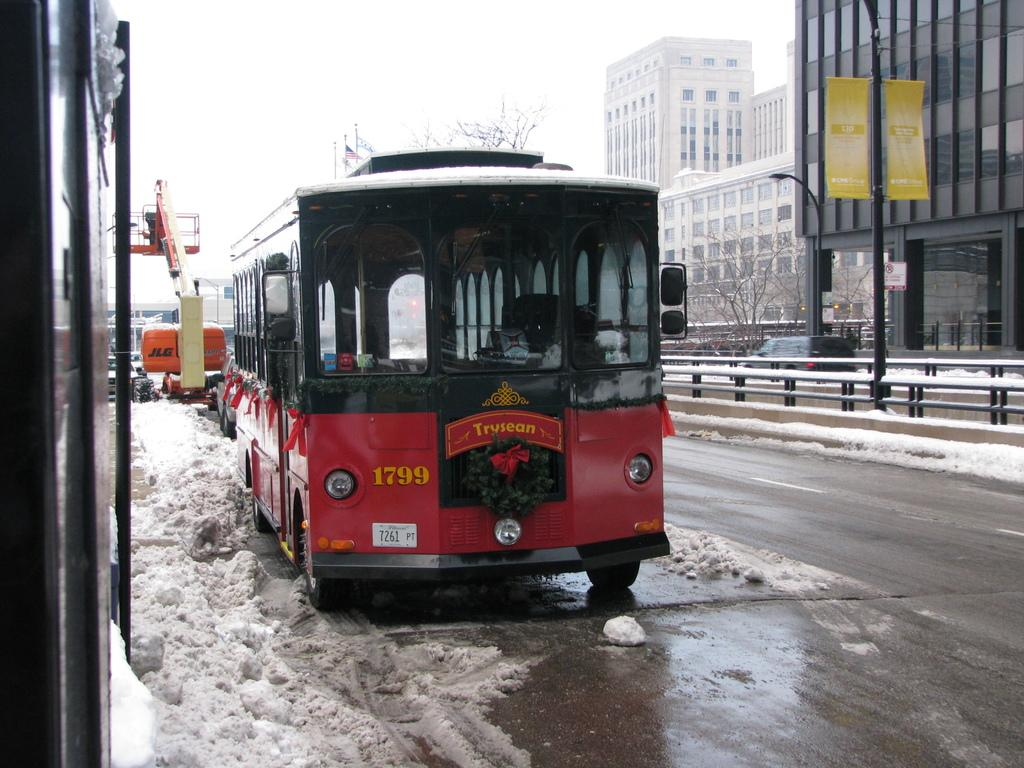Provide a one-sentence caption for the provided image. A red bus with the letters 1799 on the bottom left in yellow. 